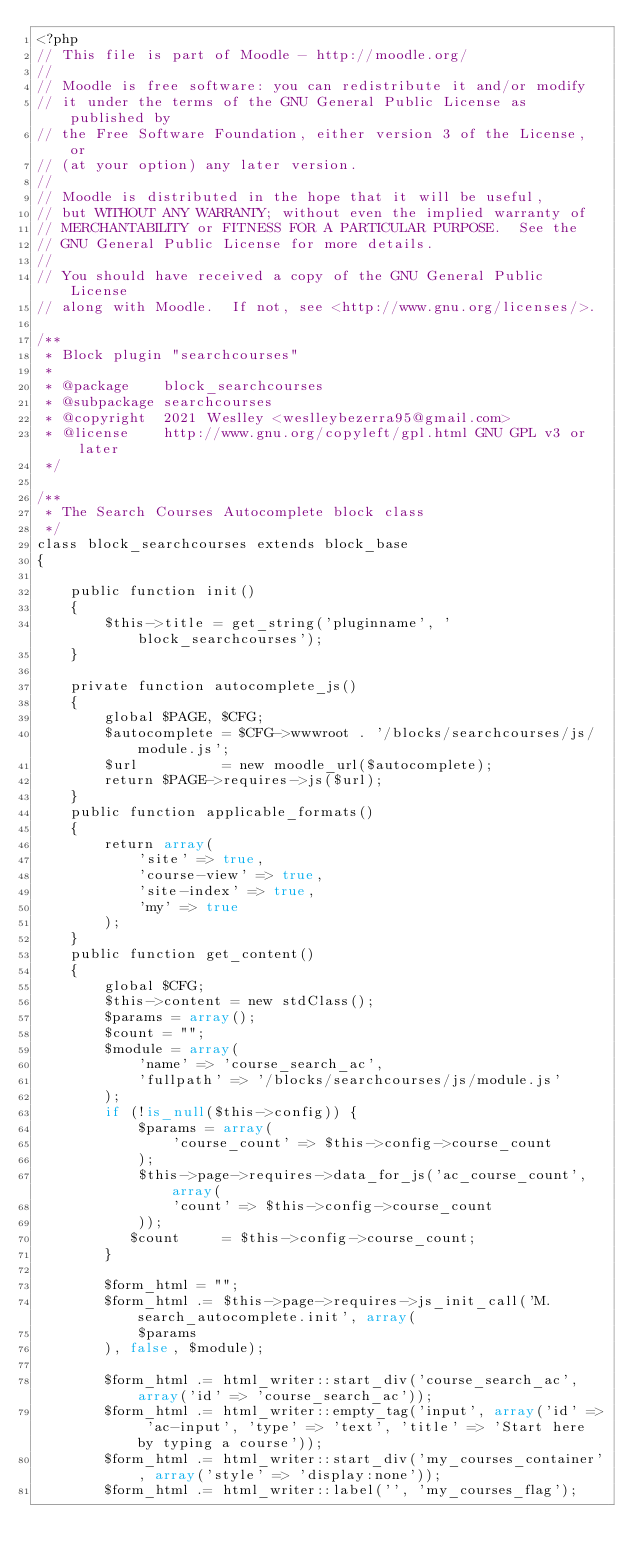Convert code to text. <code><loc_0><loc_0><loc_500><loc_500><_PHP_><?php
// This file is part of Moodle - http://moodle.org/
//
// Moodle is free software: you can redistribute it and/or modify
// it under the terms of the GNU General Public License as published by
// the Free Software Foundation, either version 3 of the License, or
// (at your option) any later version.
//
// Moodle is distributed in the hope that it will be useful,
// but WITHOUT ANY WARRANTY; without even the implied warranty of
// MERCHANTABILITY or FITNESS FOR A PARTICULAR PURPOSE.  See the
// GNU General Public License for more details.
//
// You should have received a copy of the GNU General Public License
// along with Moodle.  If not, see <http://www.gnu.org/licenses/>.

/**
 * Block plugin "searchcourses"
 *
 * @package    block_searchcourses
 * @subpackage searchcourses
 * @copyright  2021 Weslley <weslleybezerra95@gmail.com>
 * @license    http://www.gnu.org/copyleft/gpl.html GNU GPL v3 or later
 */

/**
 * The Search Courses Autocomplete block class
 */
class block_searchcourses extends block_base
{
    
    public function init()
    {
        $this->title = get_string('pluginname', 'block_searchcourses');
    }
    
    private function autocomplete_js()
    {
        global $PAGE, $CFG;
        $autocomplete = $CFG->wwwroot . '/blocks/searchcourses/js/module.js';
        $url          = new moodle_url($autocomplete);
        return $PAGE->requires->js($url);
    }
    public function applicable_formats()
    {
        return array(
            'site' => true,
            'course-view' => true,
            'site-index' => true,
            'my' => true
        );
    }
    public function get_content()
    {
        global $CFG;
        $this->content = new stdClass();
        $params = array();
        $count = "";
        $module = array(
            'name' => 'course_search_ac',
            'fullpath' => '/blocks/searchcourses/js/module.js'
        );
        if (!is_null($this->config)) {
            $params = array(
                'course_count' => $this->config->course_count
            );
            $this->page->requires->data_for_js('ac_course_count', array(
                'count' => $this->config->course_count
            ));
           $count     = $this->config->course_count;
        }

        $form_html = "";
        $form_html .= $this->page->requires->js_init_call('M.search_autocomplete.init', array(
            $params
        ), false, $module);
        
        $form_html .= html_writer::start_div('course_search_ac', array('id' => 'course_search_ac'));
        $form_html .= html_writer::empty_tag('input', array('id' => 'ac-input', 'type' => 'text', 'title' => 'Start here by typing a course'));
        $form_html .= html_writer::start_div('my_courses_container', array('style' => 'display:none'));
        $form_html .= html_writer::label('', 'my_courses_flag');</code> 